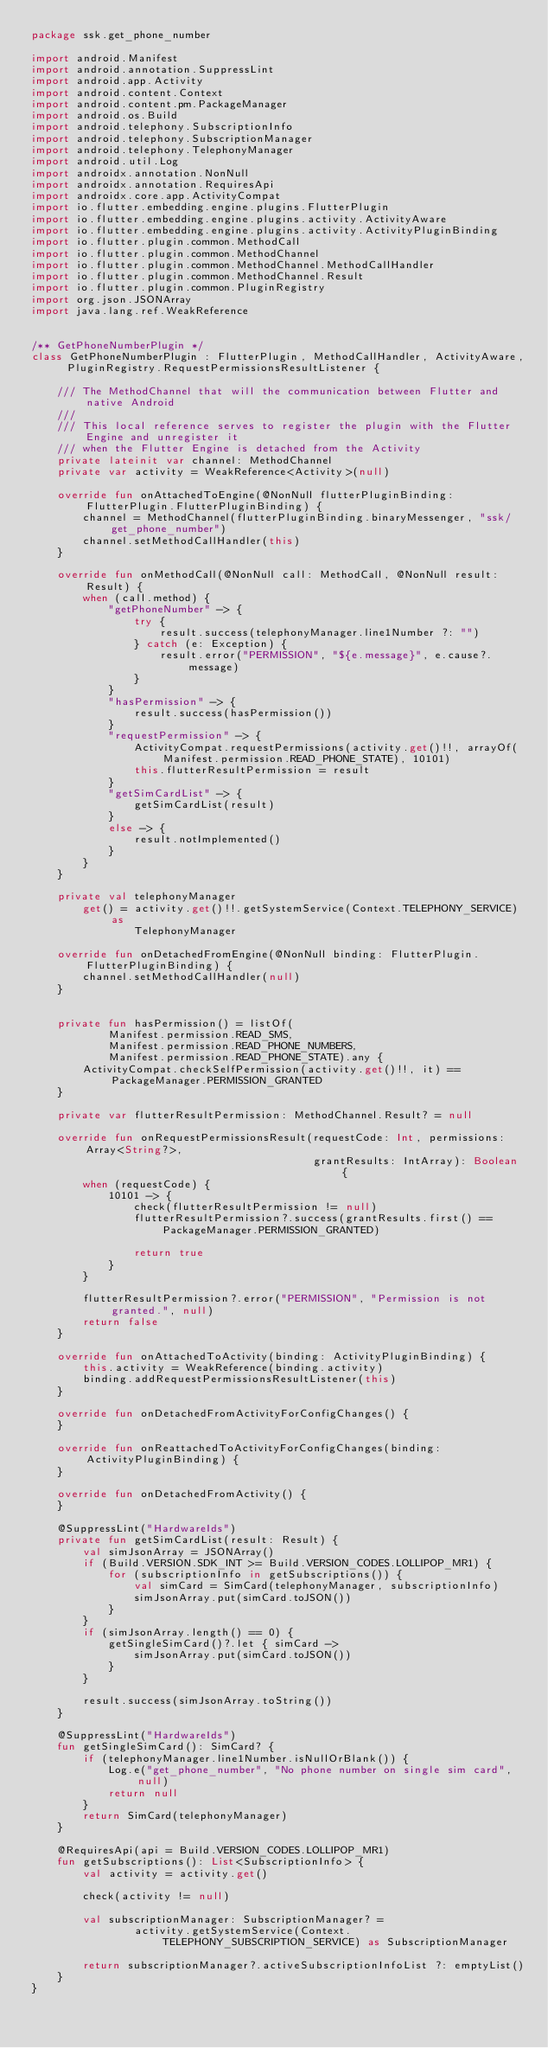<code> <loc_0><loc_0><loc_500><loc_500><_Kotlin_>package ssk.get_phone_number

import android.Manifest
import android.annotation.SuppressLint
import android.app.Activity
import android.content.Context
import android.content.pm.PackageManager
import android.os.Build
import android.telephony.SubscriptionInfo
import android.telephony.SubscriptionManager
import android.telephony.TelephonyManager
import android.util.Log
import androidx.annotation.NonNull
import androidx.annotation.RequiresApi
import androidx.core.app.ActivityCompat
import io.flutter.embedding.engine.plugins.FlutterPlugin
import io.flutter.embedding.engine.plugins.activity.ActivityAware
import io.flutter.embedding.engine.plugins.activity.ActivityPluginBinding
import io.flutter.plugin.common.MethodCall
import io.flutter.plugin.common.MethodChannel
import io.flutter.plugin.common.MethodChannel.MethodCallHandler
import io.flutter.plugin.common.MethodChannel.Result
import io.flutter.plugin.common.PluginRegistry
import org.json.JSONArray
import java.lang.ref.WeakReference


/** GetPhoneNumberPlugin */
class GetPhoneNumberPlugin : FlutterPlugin, MethodCallHandler, ActivityAware, PluginRegistry.RequestPermissionsResultListener {

    /// The MethodChannel that will the communication between Flutter and native Android
    ///
    /// This local reference serves to register the plugin with the Flutter Engine and unregister it
    /// when the Flutter Engine is detached from the Activity
    private lateinit var channel: MethodChannel
    private var activity = WeakReference<Activity>(null)

    override fun onAttachedToEngine(@NonNull flutterPluginBinding: FlutterPlugin.FlutterPluginBinding) {
        channel = MethodChannel(flutterPluginBinding.binaryMessenger, "ssk/get_phone_number")
        channel.setMethodCallHandler(this)
    }

    override fun onMethodCall(@NonNull call: MethodCall, @NonNull result: Result) {
        when (call.method) {
            "getPhoneNumber" -> {
                try {
                    result.success(telephonyManager.line1Number ?: "")
                } catch (e: Exception) {
                    result.error("PERMISSION", "${e.message}", e.cause?.message)
                }
            }
            "hasPermission" -> {
                result.success(hasPermission())
            }
            "requestPermission" -> {
                ActivityCompat.requestPermissions(activity.get()!!, arrayOf(Manifest.permission.READ_PHONE_STATE), 10101)
                this.flutterResultPermission = result
            }
            "getSimCardList" -> {
                getSimCardList(result)
            }
            else -> {
                result.notImplemented()
            }
        }
    }

    private val telephonyManager
        get() = activity.get()!!.getSystemService(Context.TELEPHONY_SERVICE) as
                TelephonyManager

    override fun onDetachedFromEngine(@NonNull binding: FlutterPlugin.FlutterPluginBinding) {
        channel.setMethodCallHandler(null)
    }


    private fun hasPermission() = listOf(
            Manifest.permission.READ_SMS,
            Manifest.permission.READ_PHONE_NUMBERS,
            Manifest.permission.READ_PHONE_STATE).any {
        ActivityCompat.checkSelfPermission(activity.get()!!, it) == PackageManager.PERMISSION_GRANTED
    }

    private var flutterResultPermission: MethodChannel.Result? = null

    override fun onRequestPermissionsResult(requestCode: Int, permissions: Array<String?>,
                                            grantResults: IntArray): Boolean {
        when (requestCode) {
            10101 -> {
                check(flutterResultPermission != null)
                flutterResultPermission?.success(grantResults.first() == PackageManager.PERMISSION_GRANTED)

                return true
            }
        }

        flutterResultPermission?.error("PERMISSION", "Permission is not granted.", null)
        return false
    }

    override fun onAttachedToActivity(binding: ActivityPluginBinding) {
        this.activity = WeakReference(binding.activity)
        binding.addRequestPermissionsResultListener(this)
    }

    override fun onDetachedFromActivityForConfigChanges() {
    }

    override fun onReattachedToActivityForConfigChanges(binding: ActivityPluginBinding) {
    }

    override fun onDetachedFromActivity() {
    }

    @SuppressLint("HardwareIds")
    private fun getSimCardList(result: Result) {
        val simJsonArray = JSONArray()
        if (Build.VERSION.SDK_INT >= Build.VERSION_CODES.LOLLIPOP_MR1) {
            for (subscriptionInfo in getSubscriptions()) {
                val simCard = SimCard(telephonyManager, subscriptionInfo)
                simJsonArray.put(simCard.toJSON())
            }
        }
        if (simJsonArray.length() == 0) {
            getSingleSimCard()?.let { simCard ->
                simJsonArray.put(simCard.toJSON())
            }
        }

        result.success(simJsonArray.toString())
    }

    @SuppressLint("HardwareIds")
    fun getSingleSimCard(): SimCard? {
        if (telephonyManager.line1Number.isNullOrBlank()) {
            Log.e("get_phone_number", "No phone number on single sim card", null)
            return null
        }
        return SimCard(telephonyManager)
    }

    @RequiresApi(api = Build.VERSION_CODES.LOLLIPOP_MR1)
    fun getSubscriptions(): List<SubscriptionInfo> {
        val activity = activity.get()

        check(activity != null)

        val subscriptionManager: SubscriptionManager? =
                activity.getSystemService(Context.TELEPHONY_SUBSCRIPTION_SERVICE) as SubscriptionManager

        return subscriptionManager?.activeSubscriptionInfoList ?: emptyList()
    }
}
</code> 